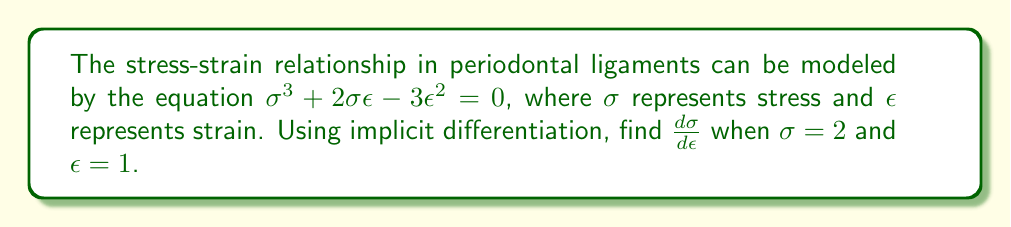Can you answer this question? 1) To find $\frac{d\sigma}{d\epsilon}$, we need to use implicit differentiation. Let's differentiate both sides of the equation with respect to $\epsilon$:

   $\frac{d}{d\epsilon}(\sigma^3 + 2\sigma\epsilon - 3\epsilon^2) = \frac{d}{d\epsilon}(0)$

2) Using the chain rule and product rule:

   $3\sigma^2\frac{d\sigma}{d\epsilon} + 2\sigma + 2\epsilon\frac{d\sigma}{d\epsilon} - 6\epsilon = 0$

3) Rearrange the equation to isolate $\frac{d\sigma}{d\epsilon}$:

   $(3\sigma^2 + 2\epsilon)\frac{d\sigma}{d\epsilon} = 6\epsilon - 2\sigma$

4) Solve for $\frac{d\sigma}{d\epsilon}$:

   $\frac{d\sigma}{d\epsilon} = \frac{6\epsilon - 2\sigma}{3\sigma^2 + 2\epsilon}$

5) Now, substitute the given values $\sigma = 2$ and $\epsilon = 1$:

   $\frac{d\sigma}{d\epsilon} = \frac{6(1) - 2(2)}{3(2)^2 + 2(1)} = \frac{6 - 4}{12 + 2} = \frac{2}{14} = \frac{1}{7}$

Therefore, when $\sigma = 2$ and $\epsilon = 1$, $\frac{d\sigma}{d\epsilon} = \frac{1}{7}$.
Answer: $\frac{1}{7}$ 